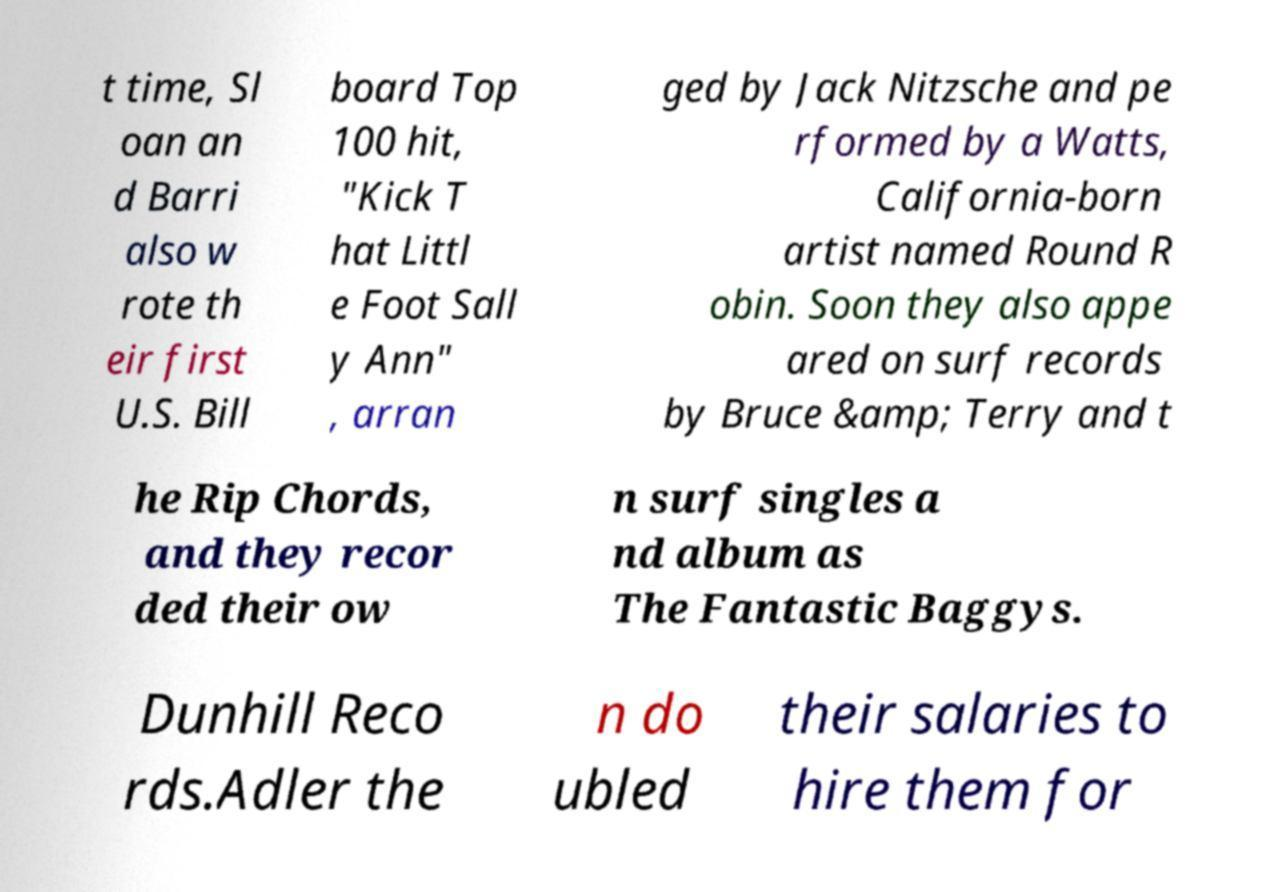Could you extract and type out the text from this image? t time, Sl oan an d Barri also w rote th eir first U.S. Bill board Top 100 hit, "Kick T hat Littl e Foot Sall y Ann" , arran ged by Jack Nitzsche and pe rformed by a Watts, California-born artist named Round R obin. Soon they also appe ared on surf records by Bruce &amp; Terry and t he Rip Chords, and they recor ded their ow n surf singles a nd album as The Fantastic Baggys. Dunhill Reco rds.Adler the n do ubled their salaries to hire them for 